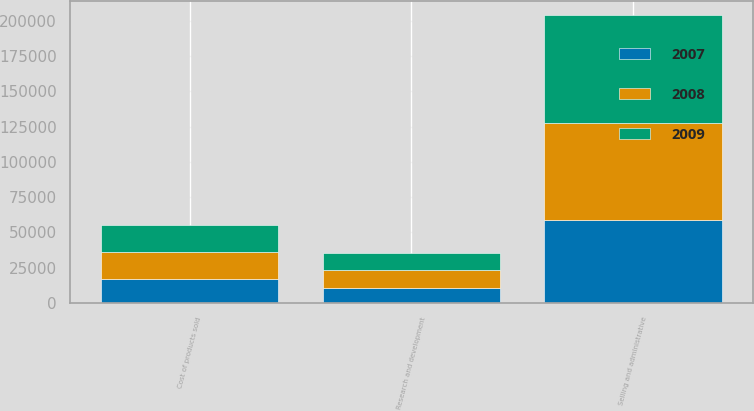Convert chart to OTSL. <chart><loc_0><loc_0><loc_500><loc_500><stacked_bar_chart><ecel><fcel>Cost of products sold<fcel>Selling and administrative<fcel>Research and development<nl><fcel>2007<fcel>16846<fcel>58920<fcel>10808<nl><fcel>2008<fcel>19338<fcel>68677<fcel>12570<nl><fcel>2009<fcel>19163<fcel>76407<fcel>12136<nl></chart> 